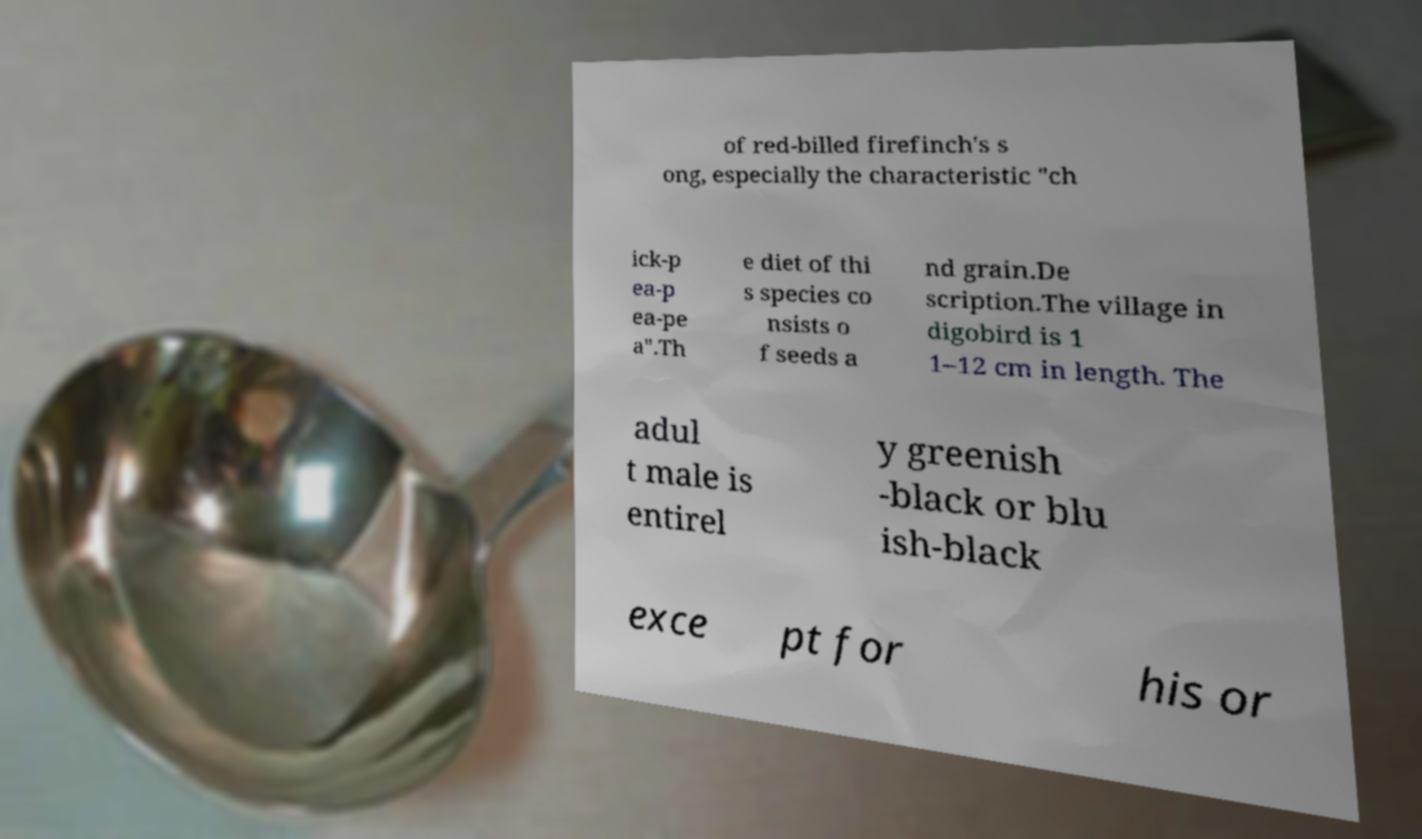Can you accurately transcribe the text from the provided image for me? of red-billed firefinch's s ong, especially the characteristic "ch ick-p ea-p ea-pe a".Th e diet of thi s species co nsists o f seeds a nd grain.De scription.The village in digobird is 1 1–12 cm in length. The adul t male is entirel y greenish -black or blu ish-black exce pt for his or 